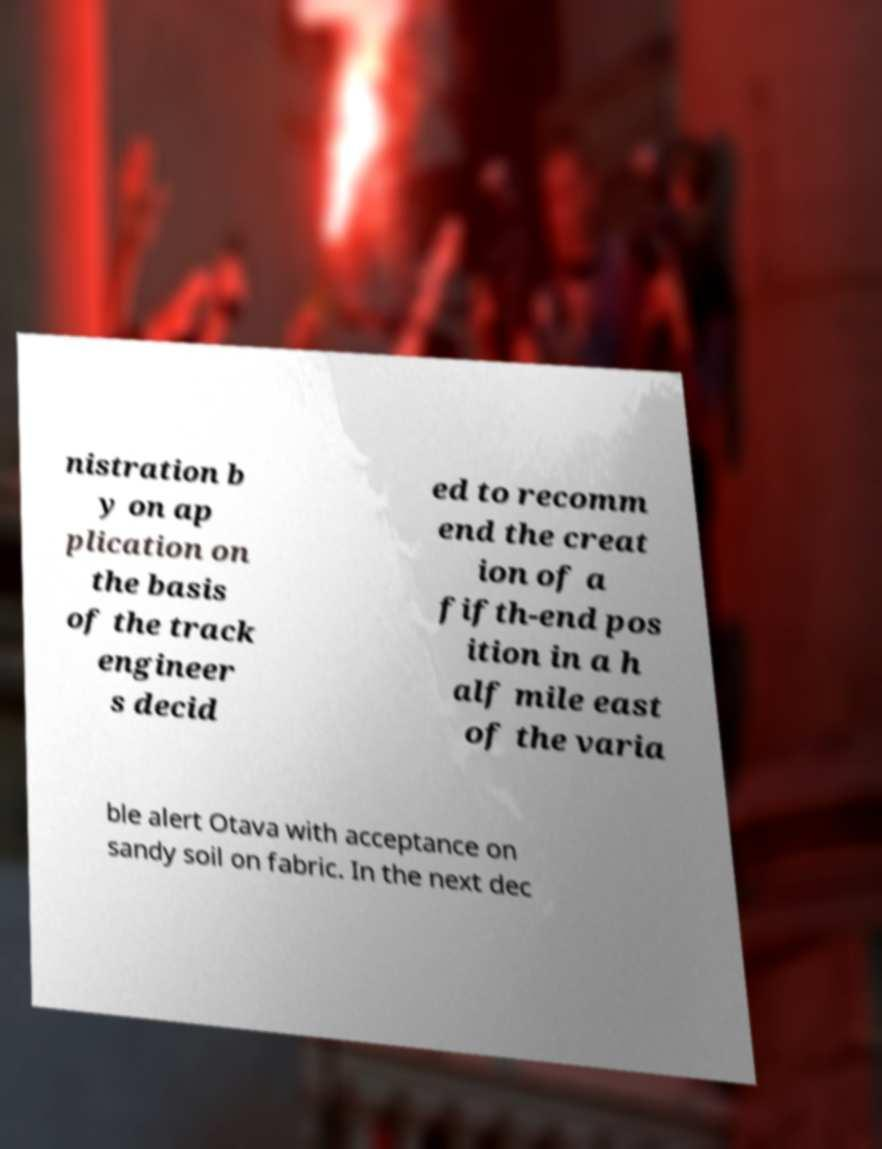Please identify and transcribe the text found in this image. nistration b y on ap plication on the basis of the track engineer s decid ed to recomm end the creat ion of a fifth-end pos ition in a h alf mile east of the varia ble alert Otava with acceptance on sandy soil on fabric. In the next dec 